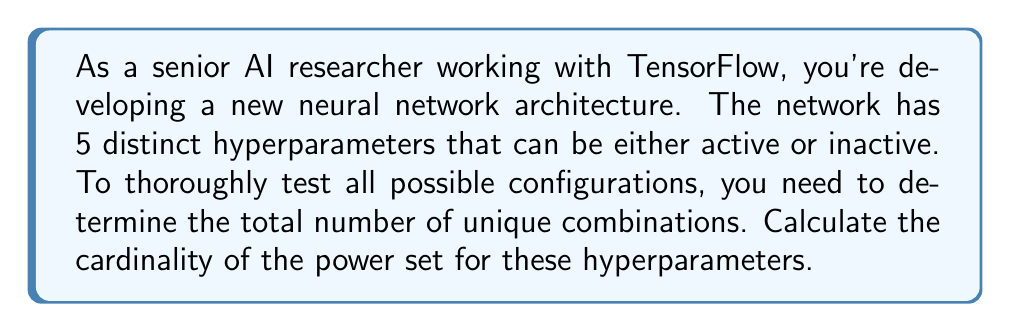Give your solution to this math problem. Let's approach this step-by-step:

1) First, we need to understand what the question is asking. We have a set of 5 hyperparameters, and each can be either active or inactive. This forms our base set.

2) The power set of a set $S$ is the set of all subsets of $S$, including the empty set and $S$ itself.

3) For a finite set with $n$ elements, the cardinality of its power set is given by the formula:

   $$|P(S)| = 2^n$$

   Where $|P(S)|$ represents the cardinality of the power set of $S$.

4) In this case, our set has 5 elements (the hyperparameters), so $n = 5$.

5) Applying the formula:

   $$|P(S)| = 2^5$$

6) Calculate $2^5$:
   
   $$2^5 = 2 \times 2 \times 2 \times 2 \times 2 = 32$$

7) Therefore, the cardinality of the power set is 32.

This result means that there are 32 unique combinations of hyperparameter configurations, including the case where all are inactive (empty set) and where all are active (the full set).
Answer: The cardinality of the power set is 32. 